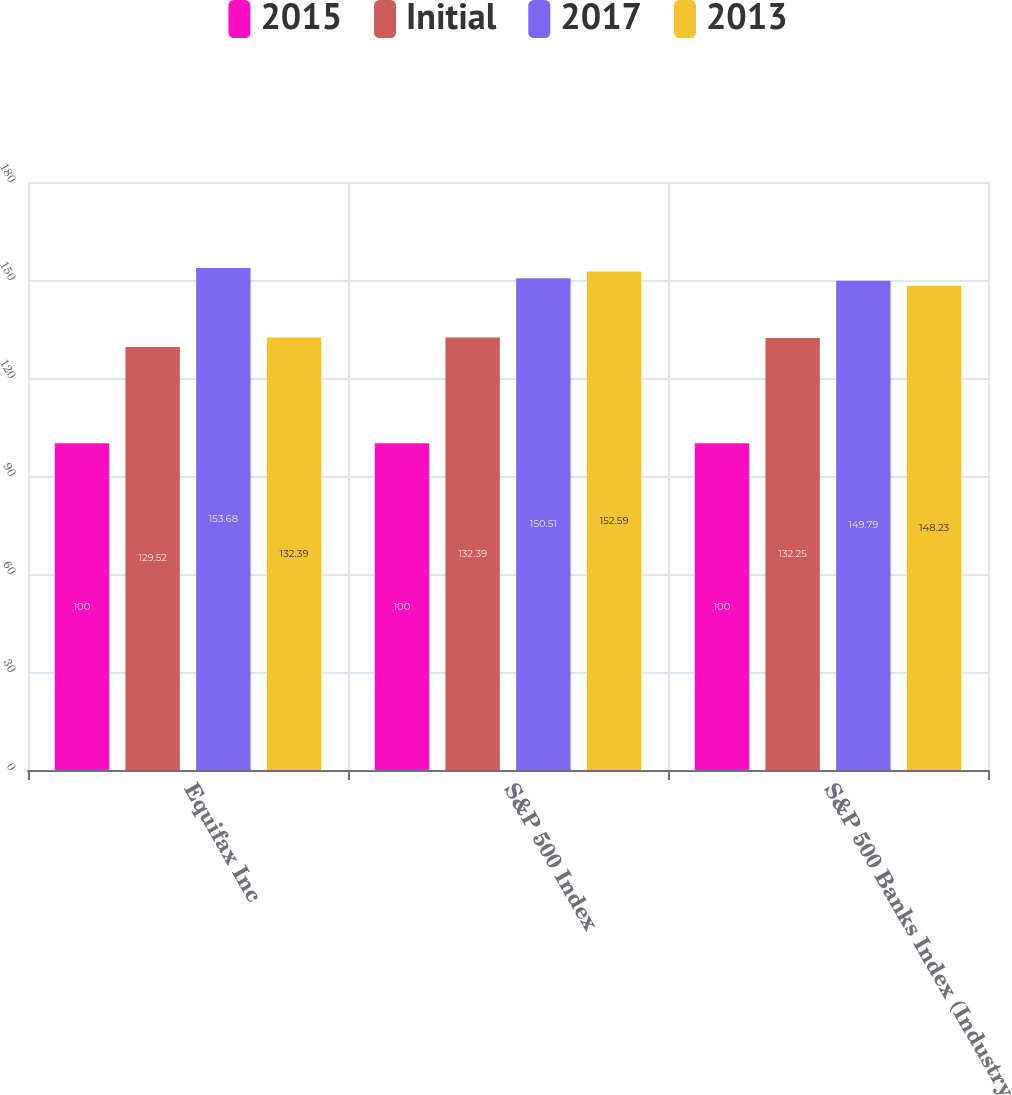<chart> <loc_0><loc_0><loc_500><loc_500><stacked_bar_chart><ecel><fcel>Equifax Inc<fcel>S&P 500 Index<fcel>S&P 500 Banks Index (Industry<nl><fcel>2015<fcel>100<fcel>100<fcel>100<nl><fcel>Initial<fcel>129.52<fcel>132.39<fcel>132.25<nl><fcel>2017<fcel>153.68<fcel>150.51<fcel>149.79<nl><fcel>2013<fcel>132.39<fcel>152.59<fcel>148.23<nl></chart> 